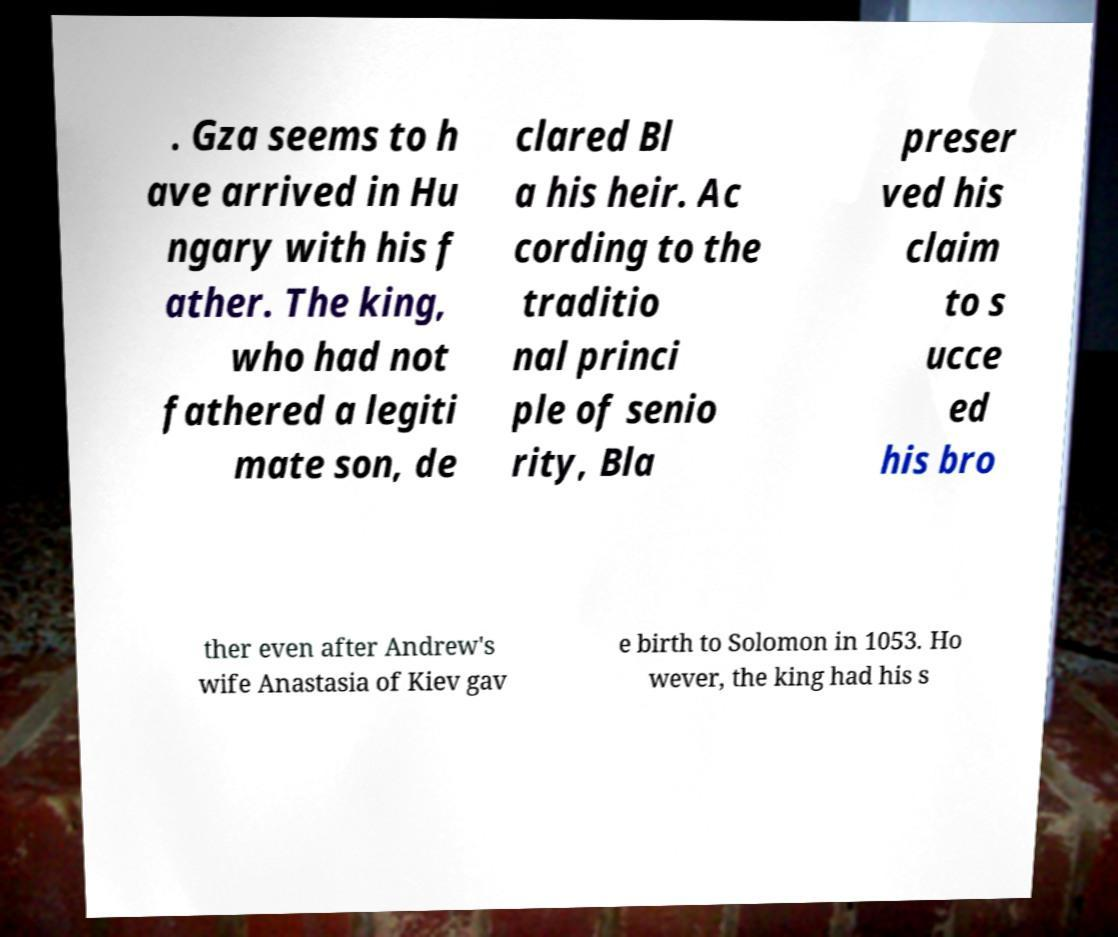Please identify and transcribe the text found in this image. . Gza seems to h ave arrived in Hu ngary with his f ather. The king, who had not fathered a legiti mate son, de clared Bl a his heir. Ac cording to the traditio nal princi ple of senio rity, Bla preser ved his claim to s ucce ed his bro ther even after Andrew's wife Anastasia of Kiev gav e birth to Solomon in 1053. Ho wever, the king had his s 